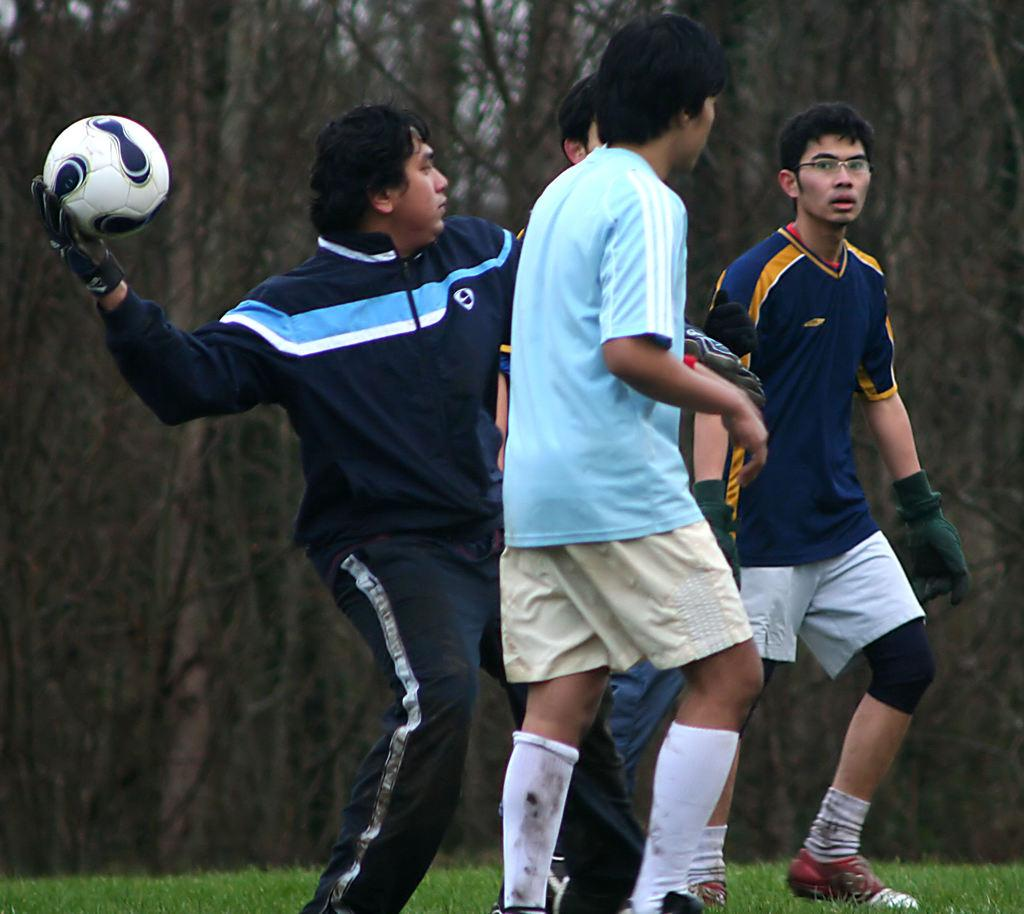How many people are in the image? There are four people in the image. What are the people in the image doing? The people are standing. Can you describe the person on the left side of the image? The person on the left side is holding a ball. What can be seen in the background of the image? There are trees visible in the background of the image. What is the condition of the market in the image? There is no market present in the image. Is the person on the left side of the image wearing a watch? The image does not provide information about the person's clothing or accessories. 